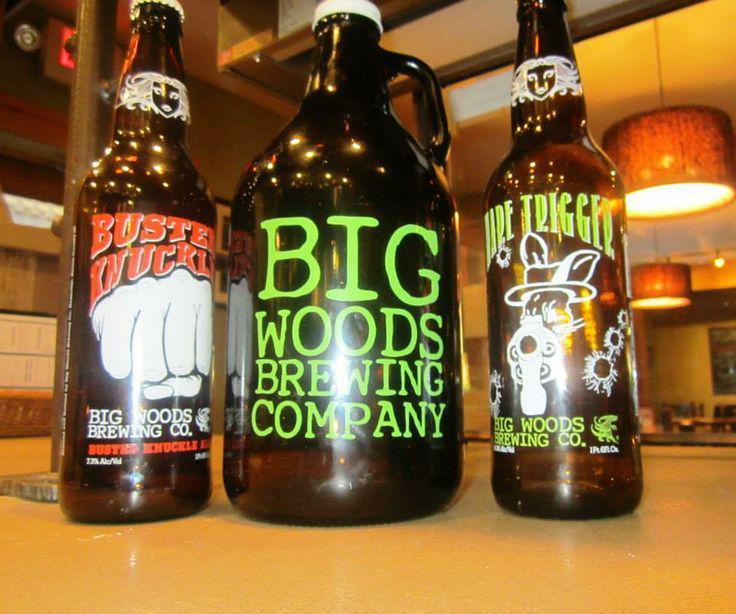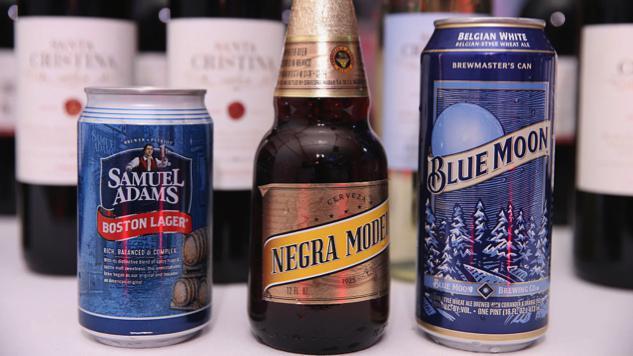The first image is the image on the left, the second image is the image on the right. Evaluate the accuracy of this statement regarding the images: "A tall glass of beer is shown in only one image.". Is it true? Answer yes or no. No. 